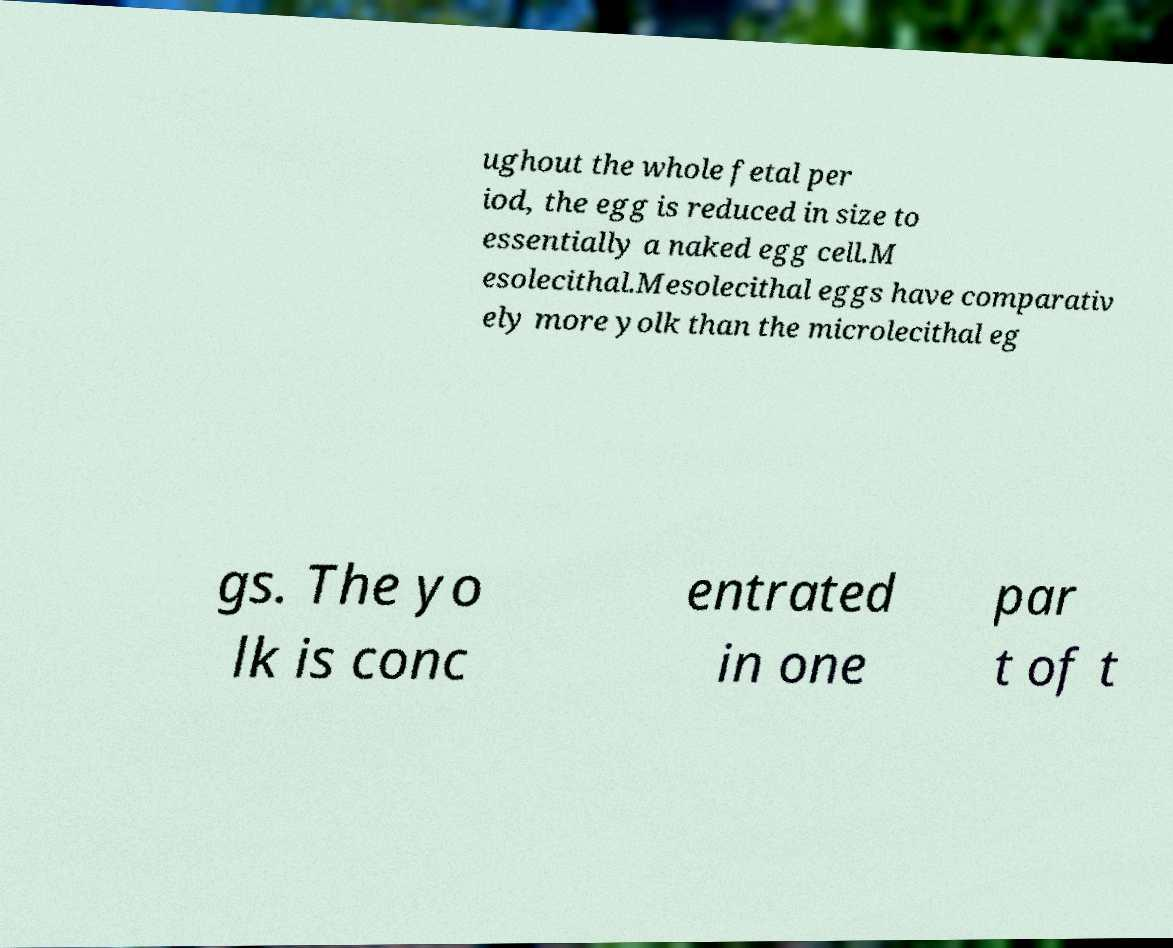For documentation purposes, I need the text within this image transcribed. Could you provide that? ughout the whole fetal per iod, the egg is reduced in size to essentially a naked egg cell.M esolecithal.Mesolecithal eggs have comparativ ely more yolk than the microlecithal eg gs. The yo lk is conc entrated in one par t of t 